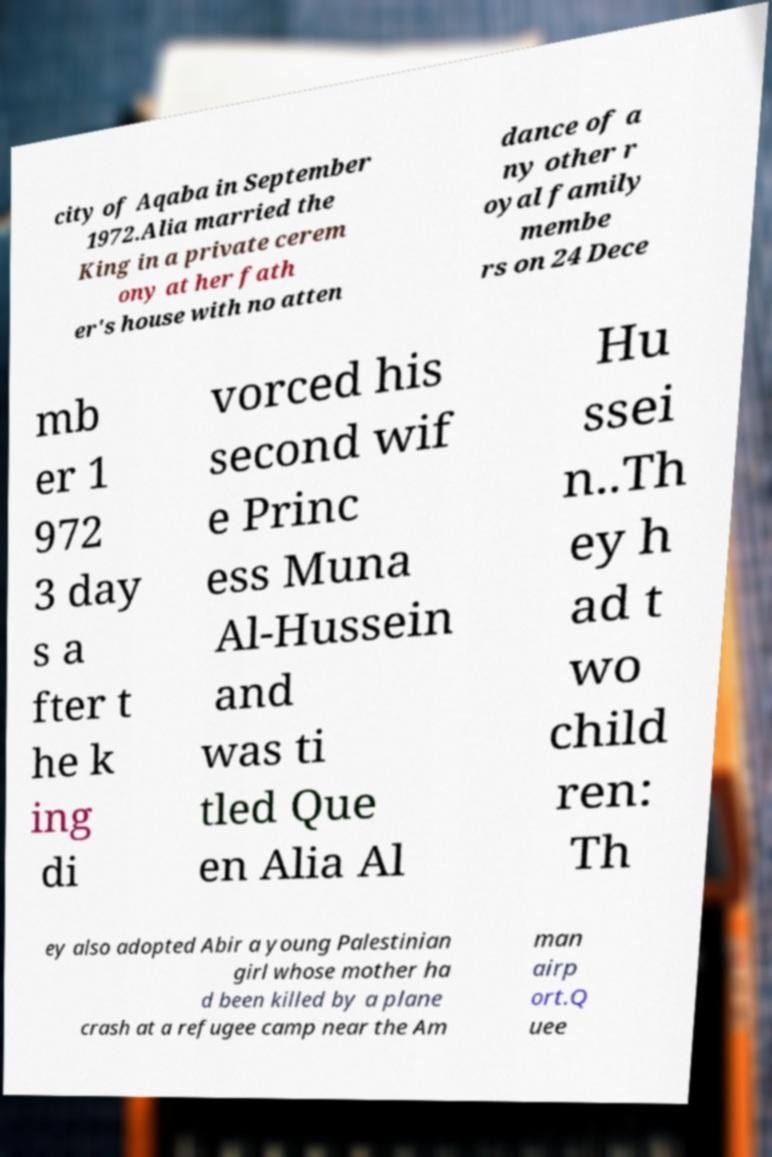Could you extract and type out the text from this image? city of Aqaba in September 1972.Alia married the King in a private cerem ony at her fath er's house with no atten dance of a ny other r oyal family membe rs on 24 Dece mb er 1 972 3 day s a fter t he k ing di vorced his second wif e Princ ess Muna Al-Hussein and was ti tled Que en Alia Al Hu ssei n..Th ey h ad t wo child ren: Th ey also adopted Abir a young Palestinian girl whose mother ha d been killed by a plane crash at a refugee camp near the Am man airp ort.Q uee 